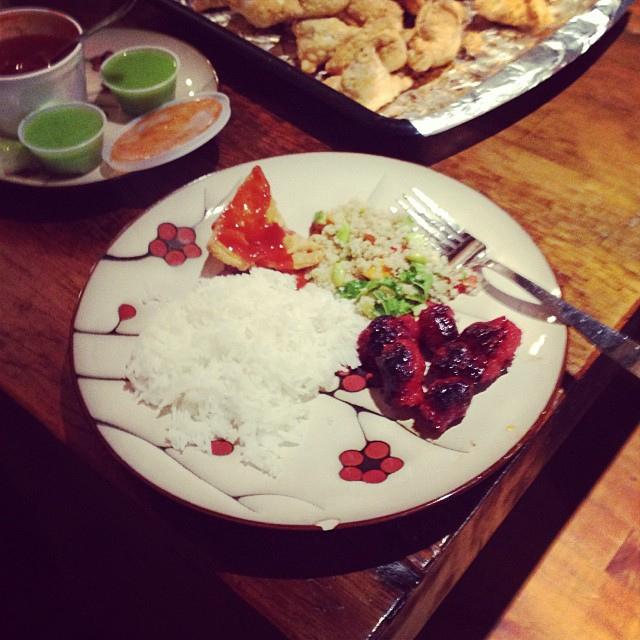What material is the plate made from?
Be succinct. Ceramic. On which side of the plate is the fork?
Give a very brief answer. Right. Why would someone eat this?
Short answer required. Hunger. 